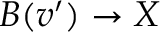<formula> <loc_0><loc_0><loc_500><loc_500>B ( v ^ { \prime } ) \rightarrow X</formula> 